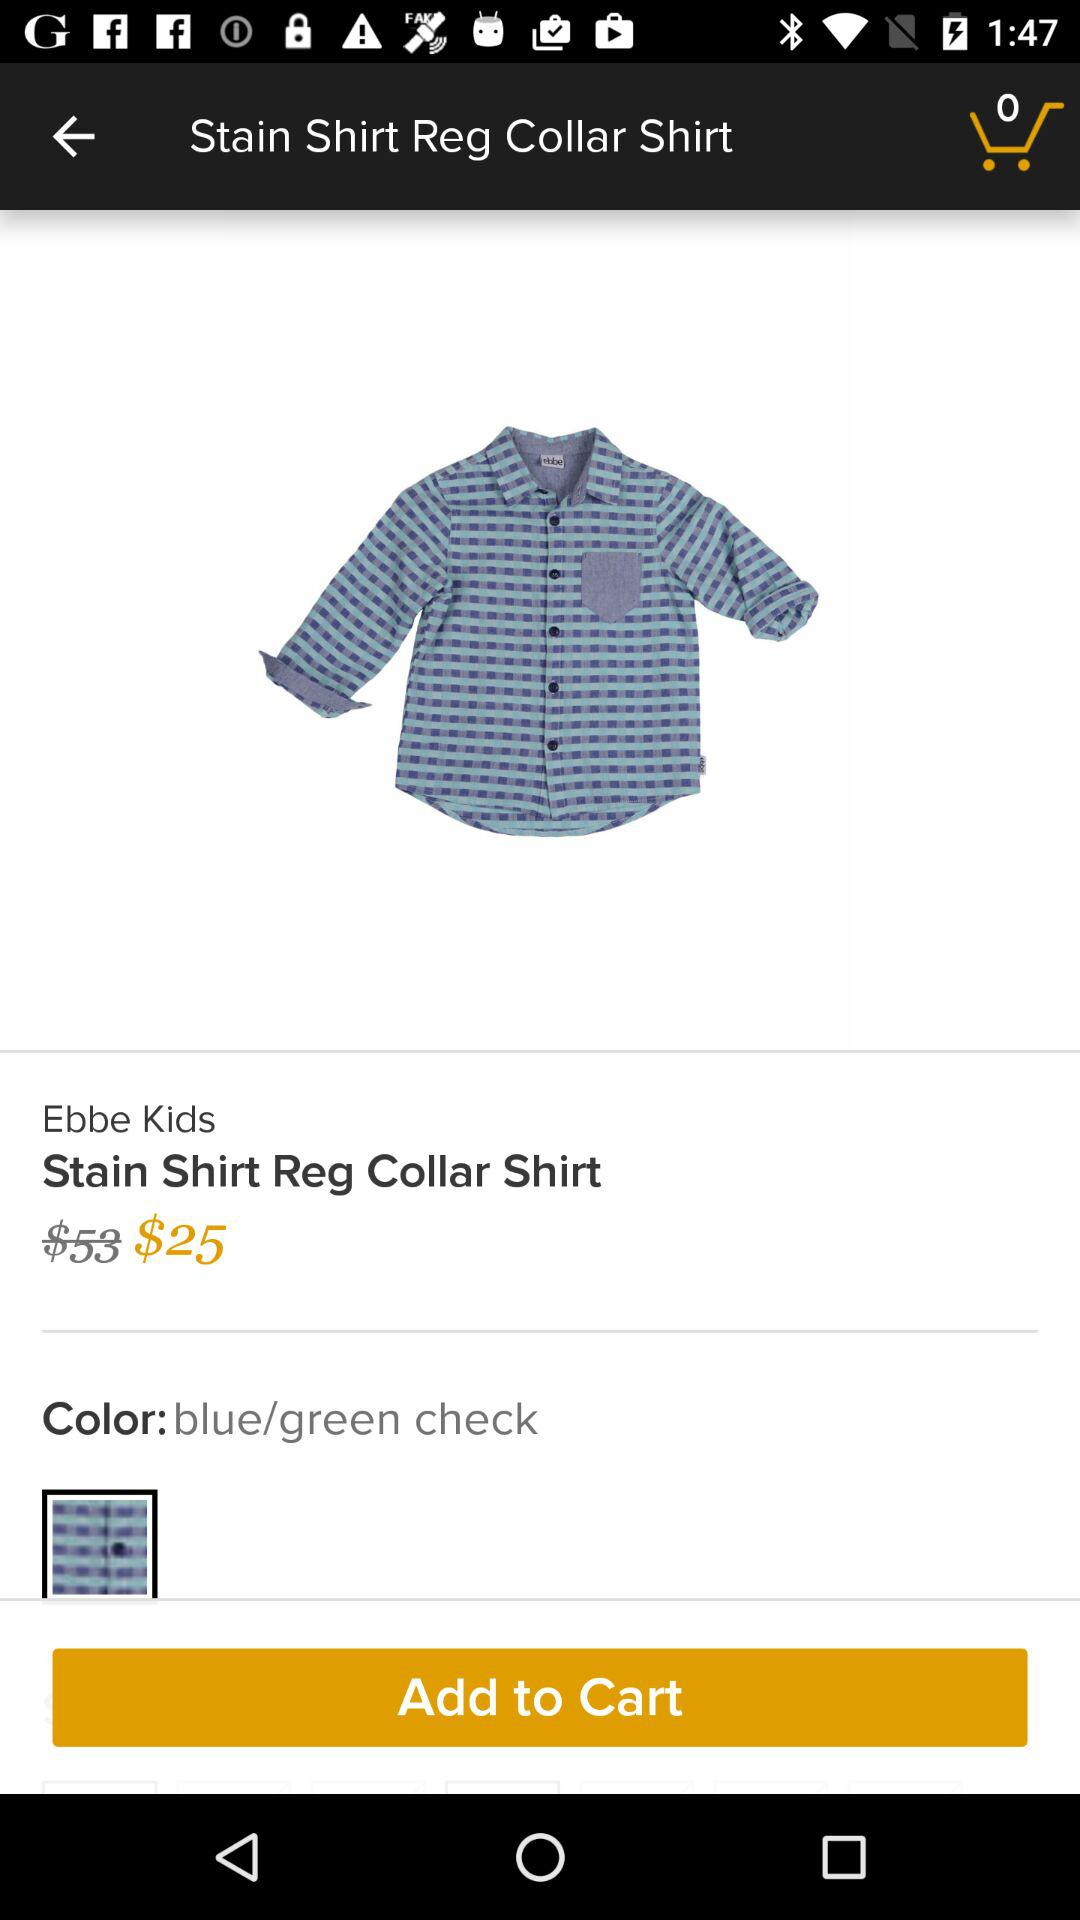What is the name of the brand? The name of the brand is Stain Shirt Reg Collar Shirt. 